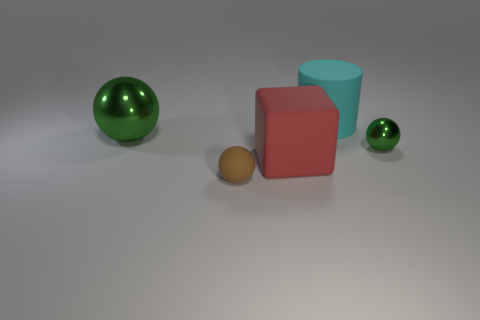Subtract all tiny spheres. How many spheres are left? 1 Add 3 large gray cylinders. How many objects exist? 8 Subtract all spheres. How many objects are left? 2 Add 5 green metallic balls. How many green metallic balls are left? 7 Add 4 cylinders. How many cylinders exist? 5 Subtract 0 yellow balls. How many objects are left? 5 Subtract all tiny brown balls. Subtract all large red matte cubes. How many objects are left? 3 